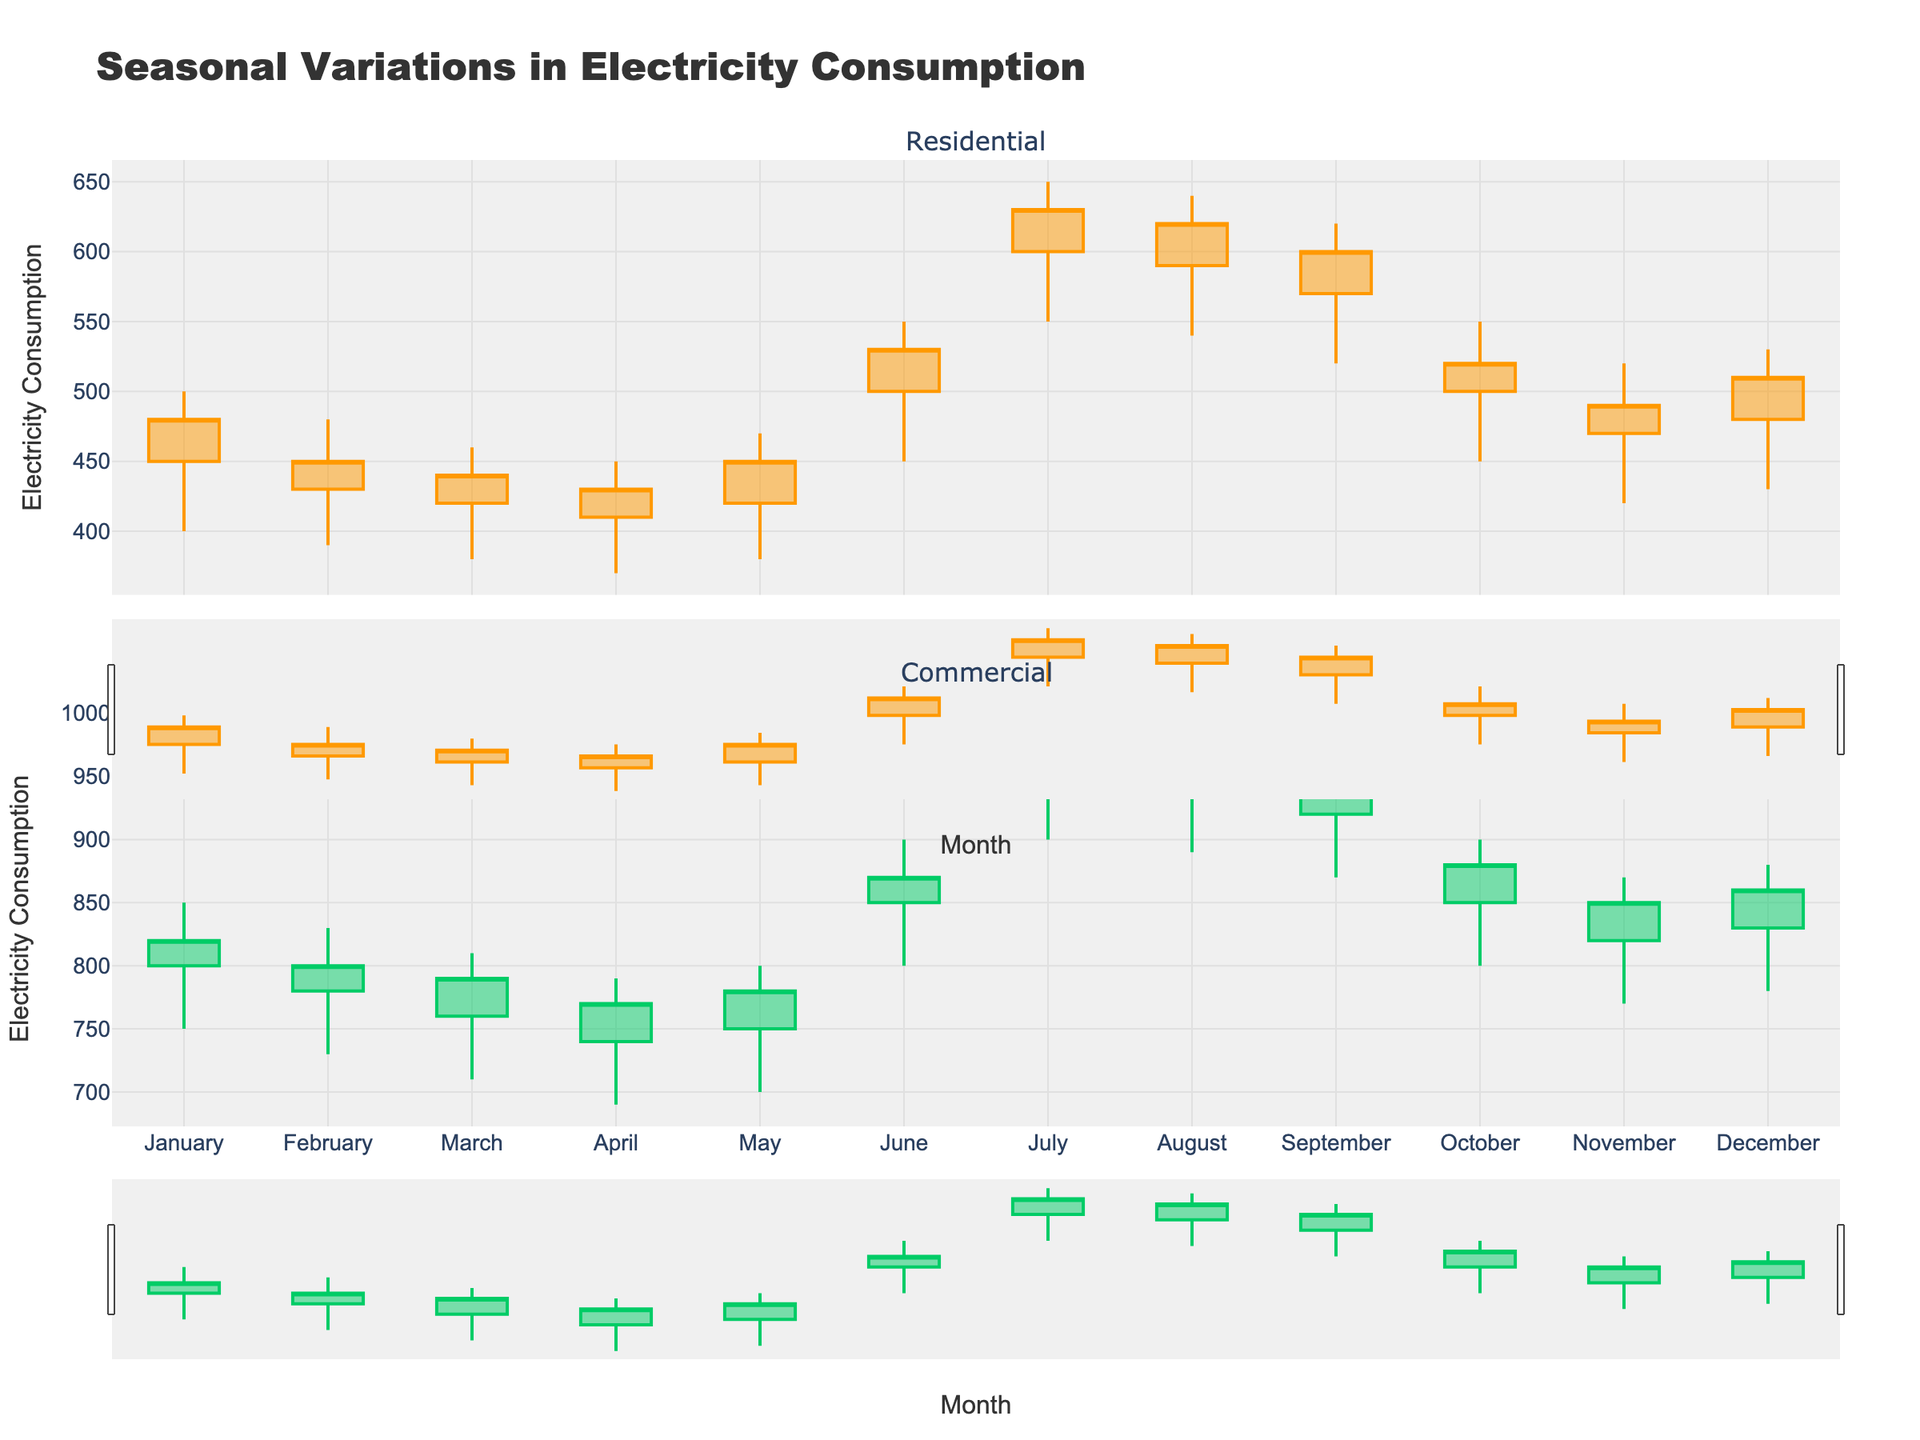What is the title of the plot? The title of the plot is located at the top of the visual. Reading the title text reveals that the plot shows "Seasonal Variations in Electricity Consumption."
Answer: Seasonal Variations in Electricity Consumption How many subplots are there in the figure? By observing the figure, it can be seen that there are two separate sections, one above the other. These are the subplots for Residential and Commercial users.
Answer: 2 Which months have the highest electricity consumption for both user types? For Residential users, the highest high value is in July. For Commercial users, the highest high value is also in July.
Answer: July What are the colors used for increasing trends in both subplots? The colors for increasing trends can be identified by looking at the candlestick lines that go upward. In the Residential subplot, increasing trends are marked in orange, while in the Commercial subplot, they are marked in green.
Answer: Orange for Residential, Green for Commercial Which month shows the lowest closing value for Residential users? By examining the closing values (the bottom part of the rectangle), March has the lowest closing value among the Residential users.
Answer: March In which month does Commercial consumption drop compared to the previous month? Observing the close values from one month to the next, the Commercial subplot shows a decrease from January to February and from June to July.
Answer: February and July What is the highest closing value for Residential users and in which month does it occur? The highest closing value among the Residential users is located by observing the top line within the candlestick plots, which occurs in July.
Answer: 630 in July How does the difference between the highest and lowest values change from January to February for Commercial users? January: 850 - 750 = 100 and February: 830 - 730 = 100. Comparing these differences, the range remains the same.
Answer: The difference stays the same at 100 Which user type generally has higher electricity consumption values throughout the year? By comparing the high, low, open, and close values in both subplots consistently, it becomes evident that the Commercial users have higher electricity consumption values.
Answer: Commercial What is the largest difference between opening and closing values for any given month in the Residential subplot? Comparing the absolute differences between open and close values for each month reveals that the largest difference is in January (480 - 450 = 30).
Answer: 30 in January 